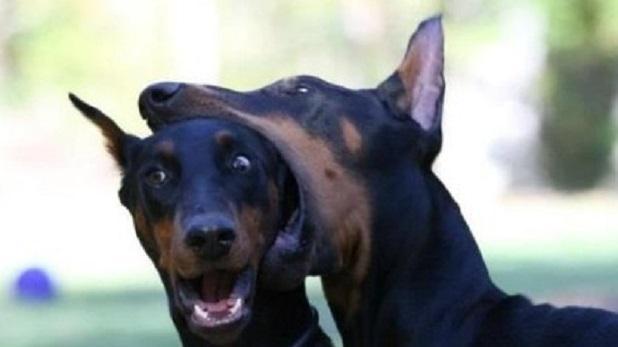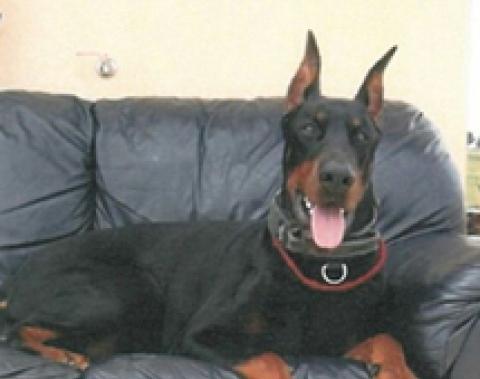The first image is the image on the left, the second image is the image on the right. Analyze the images presented: Is the assertion "The right image contains exactly two dogs." valid? Answer yes or no. No. The first image is the image on the left, the second image is the image on the right. Assess this claim about the two images: "The left image shows two forward-turned dobermans with pointy ears and collars posed side-by-side, and the right image shows two dobermans interacting with their noses close together.". Correct or not? Answer yes or no. No. 